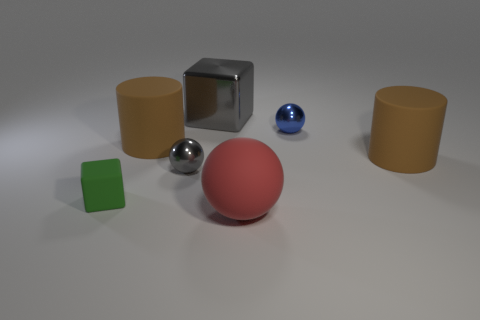What material is the tiny sphere that is the same color as the big block?
Your answer should be compact. Metal. There is a small shiny object that is on the left side of the matte sphere; does it have the same color as the cube that is behind the tiny blue metal object?
Ensure brevity in your answer.  Yes. Are there fewer green objects that are right of the blue thing than tiny objects?
Provide a succinct answer. Yes. There is a sphere in front of the green rubber thing; what is its color?
Provide a short and direct response. Red. What is the material of the tiny object behind the brown cylinder right of the red matte ball?
Your answer should be very brief. Metal. Is there a blue matte thing of the same size as the red object?
Your answer should be compact. No. What number of things are either matte objects left of the big red rubber sphere or large objects that are in front of the tiny gray object?
Keep it short and to the point. 3. Is the size of the brown matte cylinder on the left side of the blue ball the same as the cube that is in front of the small gray metal ball?
Ensure brevity in your answer.  No. There is a big matte cylinder that is to the left of the tiny blue shiny ball; is there a thing right of it?
Provide a short and direct response. Yes. How many tiny gray things are on the right side of the tiny blue metallic object?
Give a very brief answer. 0. 